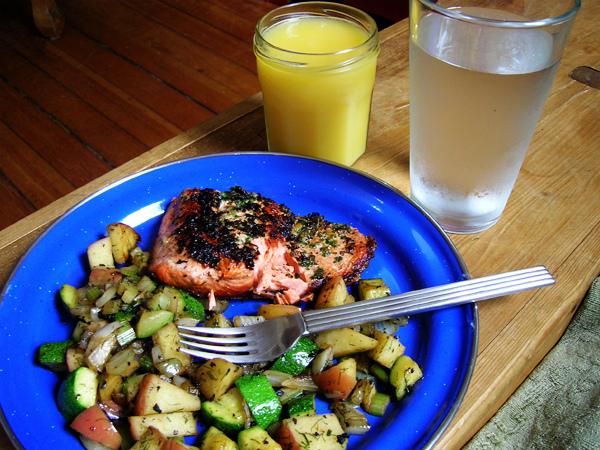Which fruit is sometimes sliced and fried as a treat?
Be succinct. Apple. Is the person eating this meal vegan?
Give a very brief answer. No. What is the plate made of?
Quick response, please. Plastic. What kind of meat is on the plate?
Write a very short answer. Steak. What kind of meat is this?
Answer briefly. Salmon. 